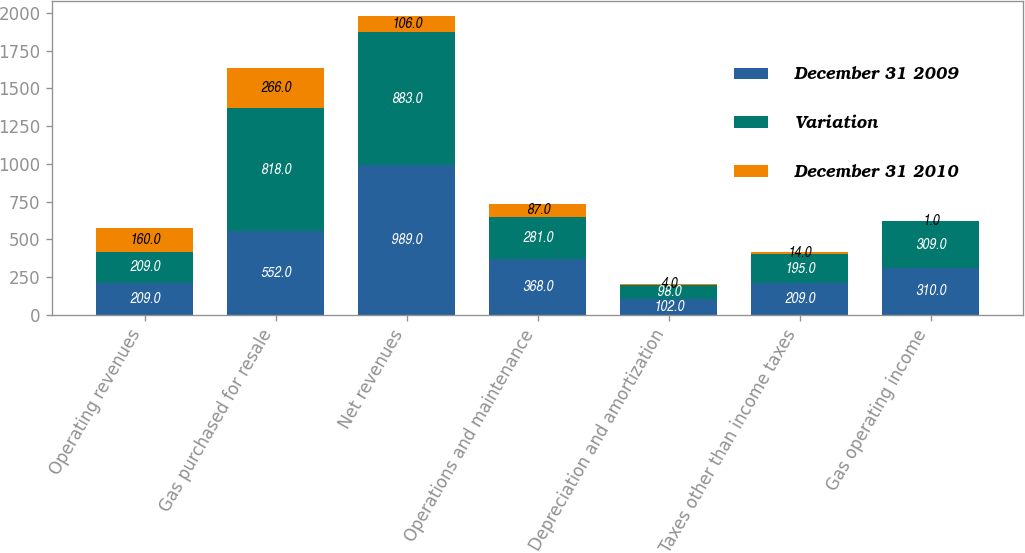Convert chart to OTSL. <chart><loc_0><loc_0><loc_500><loc_500><stacked_bar_chart><ecel><fcel>Operating revenues<fcel>Gas purchased for resale<fcel>Net revenues<fcel>Operations and maintenance<fcel>Depreciation and amortization<fcel>Taxes other than income taxes<fcel>Gas operating income<nl><fcel>December 31 2009<fcel>209<fcel>552<fcel>989<fcel>368<fcel>102<fcel>209<fcel>310<nl><fcel>Variation<fcel>209<fcel>818<fcel>883<fcel>281<fcel>98<fcel>195<fcel>309<nl><fcel>December 31 2010<fcel>160<fcel>266<fcel>106<fcel>87<fcel>4<fcel>14<fcel>1<nl></chart> 